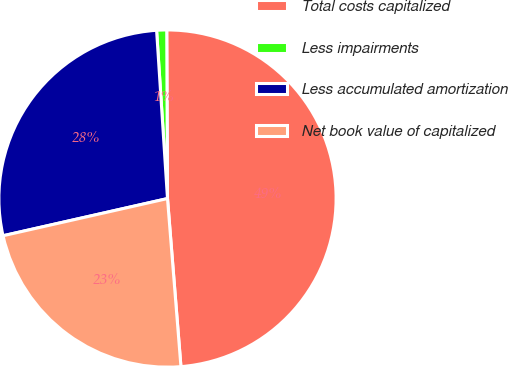<chart> <loc_0><loc_0><loc_500><loc_500><pie_chart><fcel>Total costs capitalized<fcel>Less impairments<fcel>Less accumulated amortization<fcel>Net book value of capitalized<nl><fcel>48.8%<fcel>0.96%<fcel>27.51%<fcel>22.73%<nl></chart> 